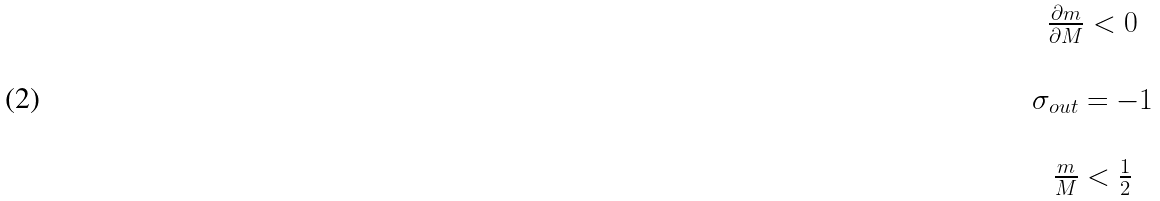<formula> <loc_0><loc_0><loc_500><loc_500>\begin{array} { c } \frac { \partial m } { \partial M } < 0 \\ \\ \sigma _ { o u t } = - 1 \\ \\ \frac { m } { M } < \frac { 1 } { 2 } \end{array}</formula> 